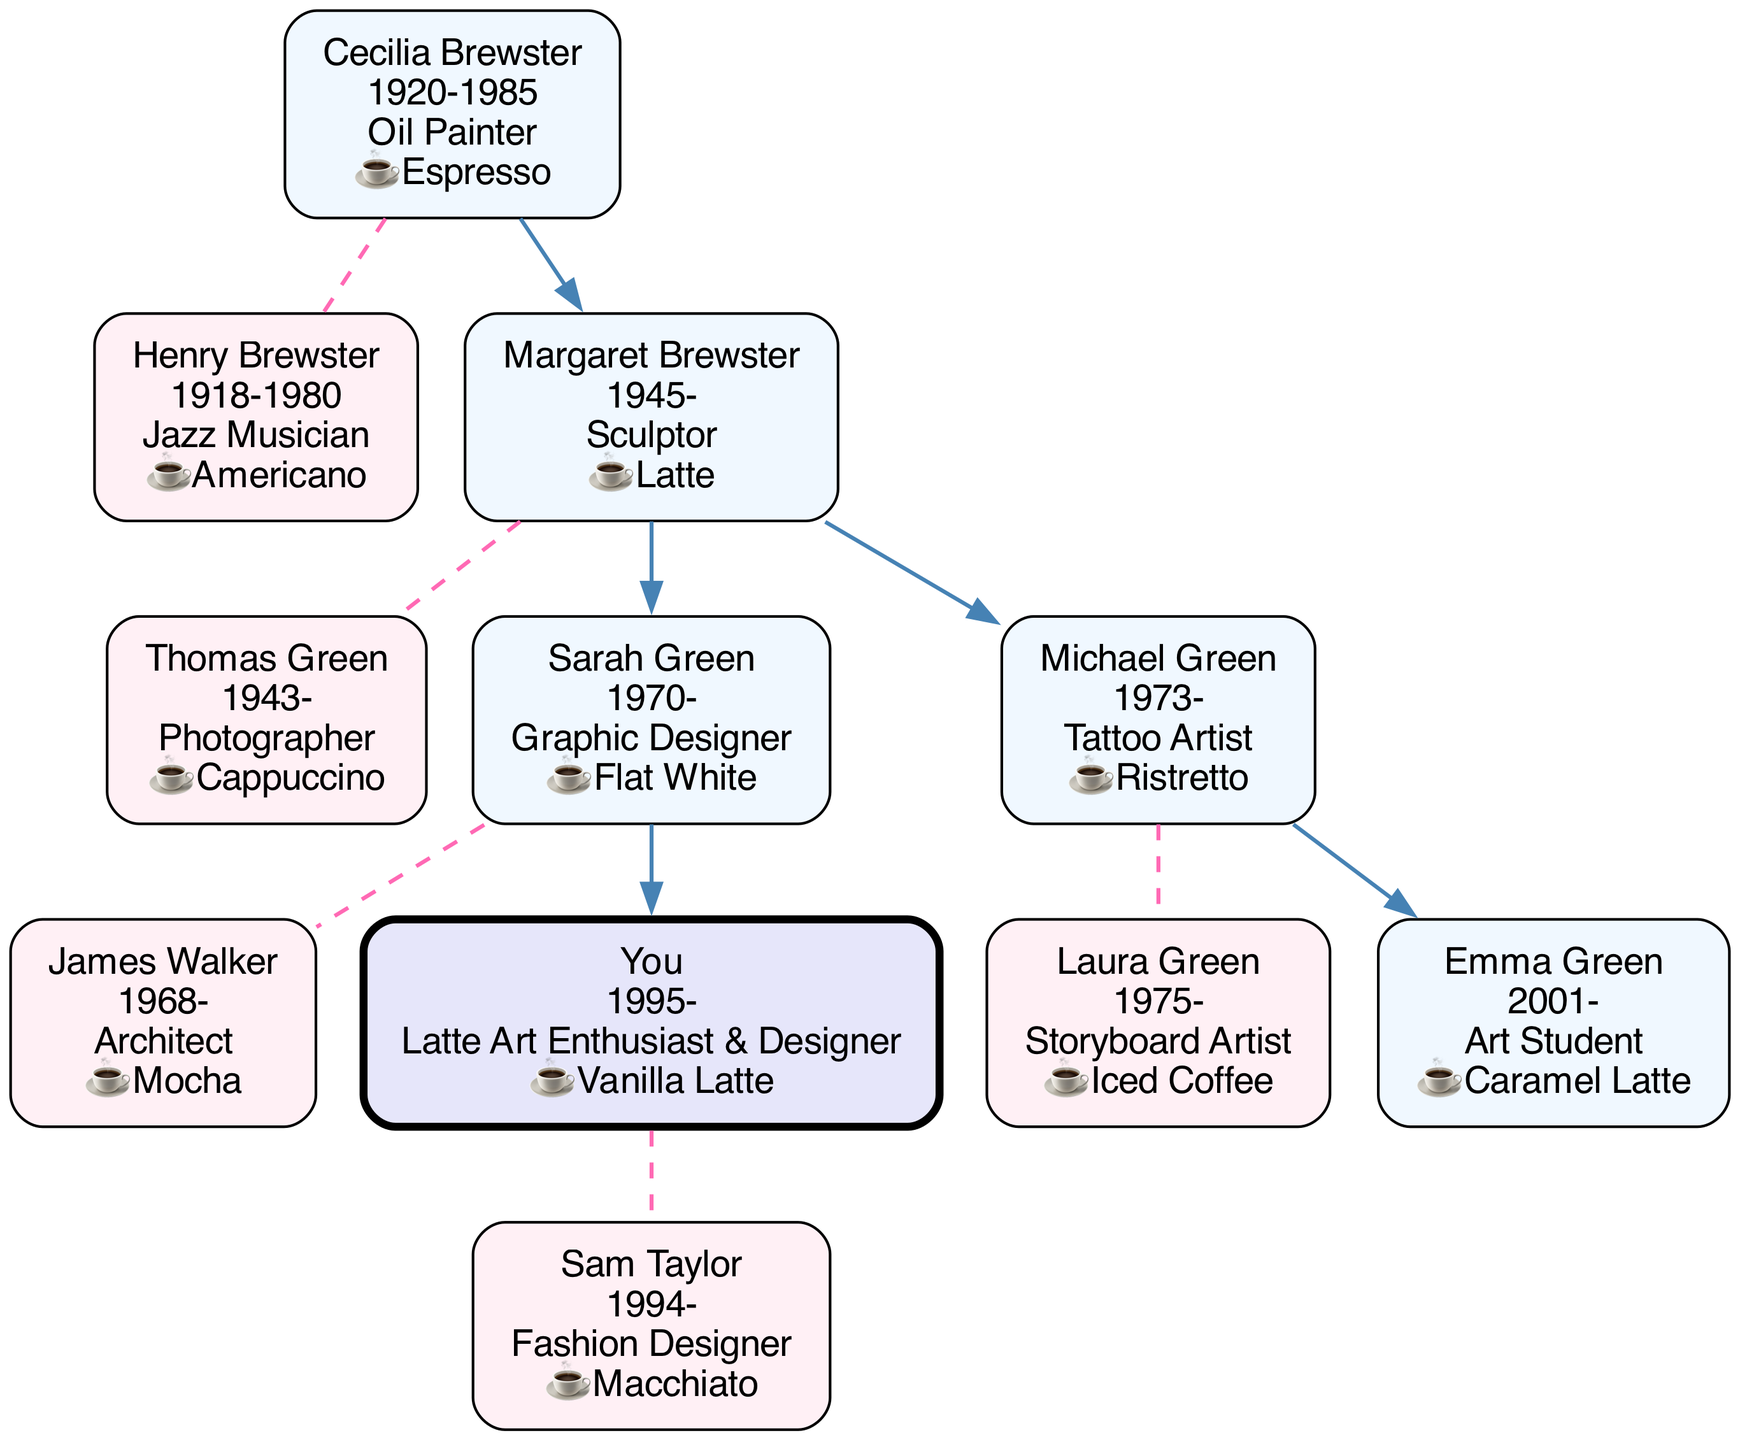What is the occupation of Cecilia Brewster? The diagram shows that Cecilia Brewster's occupation is labeled as "Oil Painter."
Answer: Oil Painter Who is the spouse of Sarah Green? In the diagram, Sarah Green's spouse is noted as James Walker.
Answer: James Walker How many children does Margaret Brewster have? By examining the diagram, we find that Margaret Brewster has two children: Sarah Green and Michael Green.
Answer: 2 What type of artist is Michael Green? The diagram indicates that Michael Green's occupation is "Tattoo Artist."
Answer: Tattoo Artist What is the favorite coffee of your cousin Emma Green? According to the diagram, Emma Green's favorite coffee is listed as "Caramel Latte."
Answer: Caramel Latte Which generation does you belong to in the family tree? The diagram places "You" in the fourth generation after Cecilia Brewster, who is the root of the family tree.
Answer: Fourth generation How is Laura Green related to you? By tracing the family connections in the diagram, we see that Laura Green is your aunt, being the spouse of your uncle, Michael Green.
Answer: Aunt Who is the great-grandmother of You? The diagram identifies Cecilia Brewster as your great-grandmother.
Answer: Cecilia Brewster What coffee drink does Henry Brewster prefer? The diagram provides the information that Henry Brewster's favorite coffee is labeled as "Americano."
Answer: Americano 